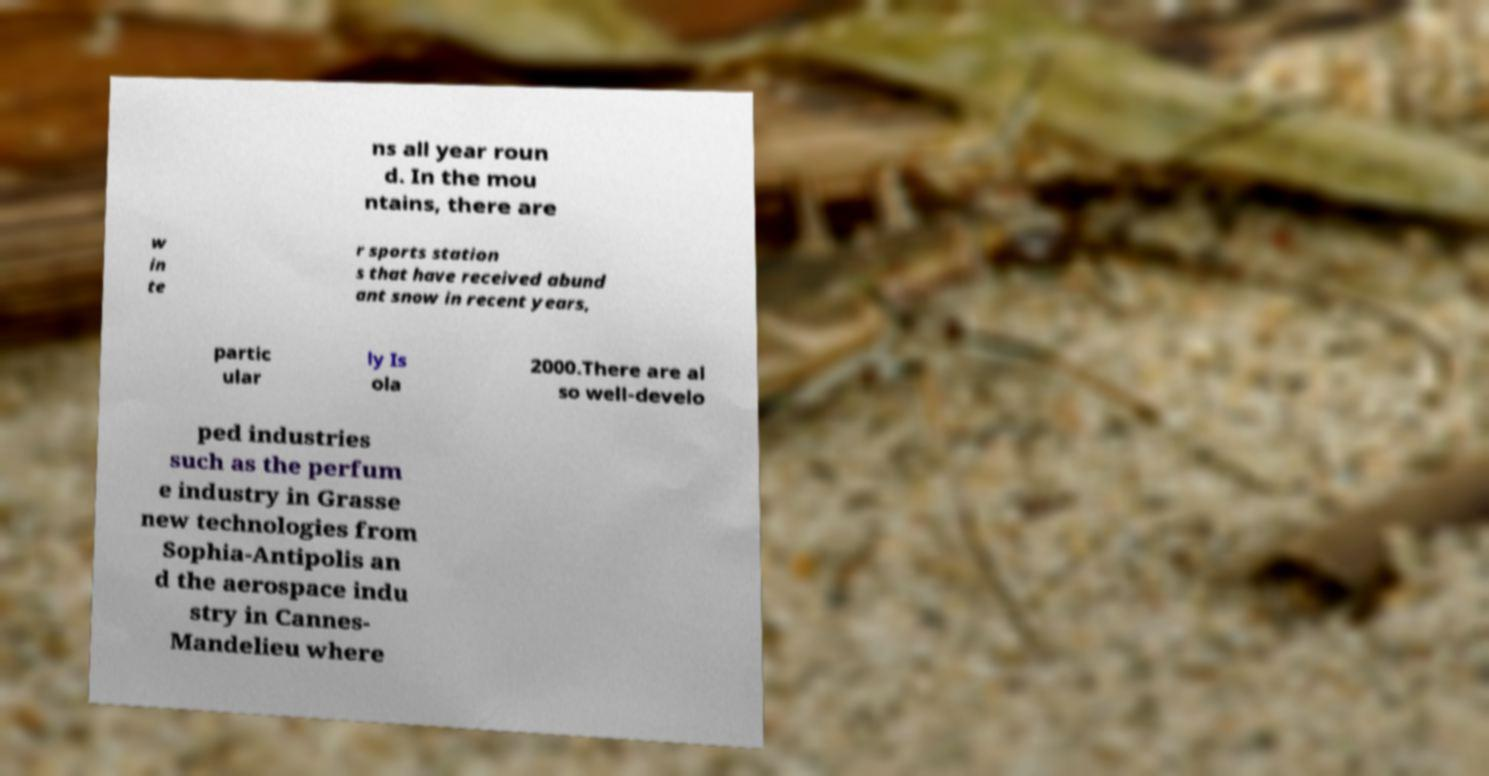For documentation purposes, I need the text within this image transcribed. Could you provide that? ns all year roun d. In the mou ntains, there are w in te r sports station s that have received abund ant snow in recent years, partic ular ly Is ola 2000.There are al so well-develo ped industries such as the perfum e industry in Grasse new technologies from Sophia-Antipolis an d the aerospace indu stry in Cannes- Mandelieu where 